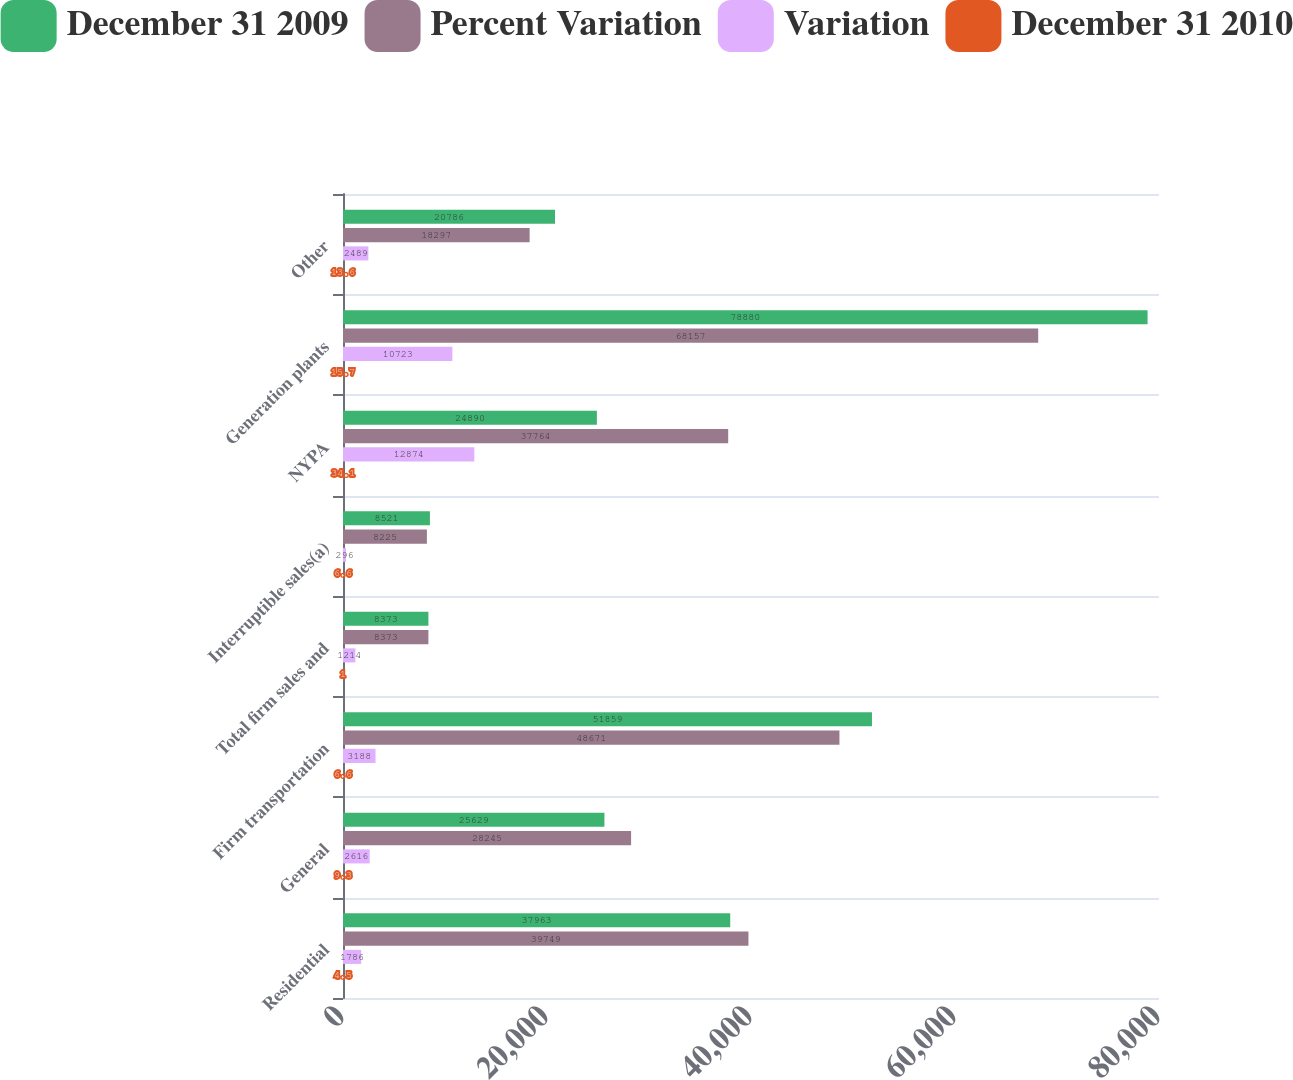Convert chart to OTSL. <chart><loc_0><loc_0><loc_500><loc_500><stacked_bar_chart><ecel><fcel>Residential<fcel>General<fcel>Firm transportation<fcel>Total firm sales and<fcel>Interruptible sales(a)<fcel>NYPA<fcel>Generation plants<fcel>Other<nl><fcel>December 31 2009<fcel>37963<fcel>25629<fcel>51859<fcel>8373<fcel>8521<fcel>24890<fcel>78880<fcel>20786<nl><fcel>Percent Variation<fcel>39749<fcel>28245<fcel>48671<fcel>8373<fcel>8225<fcel>37764<fcel>68157<fcel>18297<nl><fcel>Variation<fcel>1786<fcel>2616<fcel>3188<fcel>1214<fcel>296<fcel>12874<fcel>10723<fcel>2489<nl><fcel>December 31 2010<fcel>4.5<fcel>9.3<fcel>6.6<fcel>1<fcel>6.6<fcel>34.1<fcel>15.7<fcel>13.6<nl></chart> 